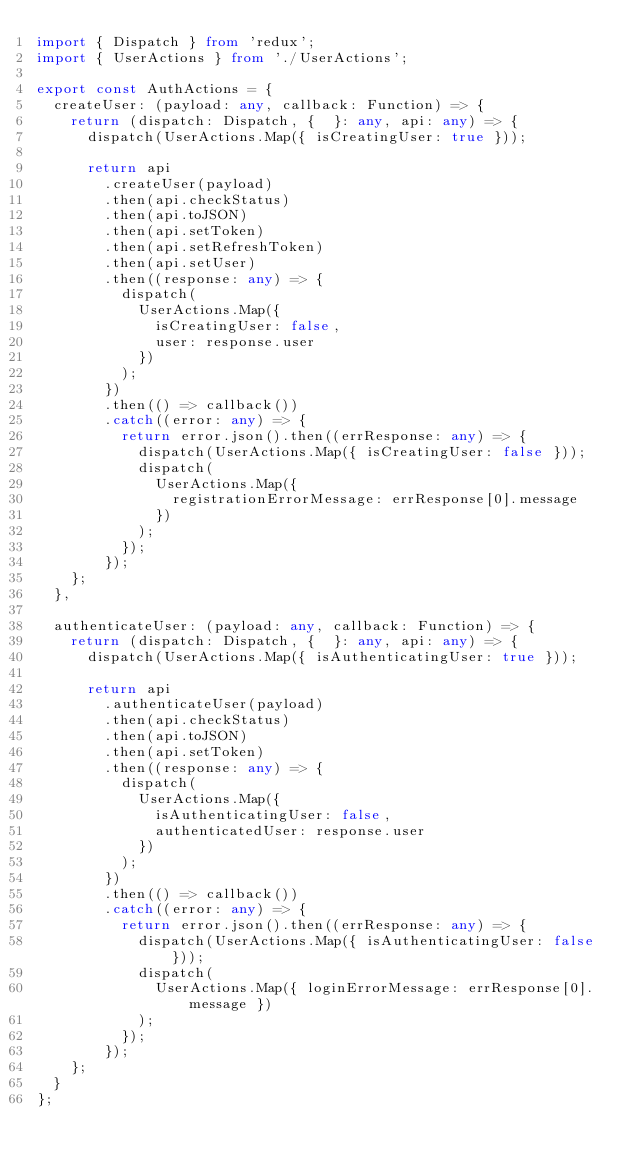Convert code to text. <code><loc_0><loc_0><loc_500><loc_500><_TypeScript_>import { Dispatch } from 'redux';
import { UserActions } from './UserActions';

export const AuthActions = {
  createUser: (payload: any, callback: Function) => {
    return (dispatch: Dispatch, {  }: any, api: any) => {
      dispatch(UserActions.Map({ isCreatingUser: true }));

      return api
        .createUser(payload)
        .then(api.checkStatus)
        .then(api.toJSON)
        .then(api.setToken)
        .then(api.setRefreshToken)
        .then(api.setUser)
        .then((response: any) => {
          dispatch(
            UserActions.Map({
              isCreatingUser: false,
              user: response.user
            })
          );
        })
        .then(() => callback())
        .catch((error: any) => {
          return error.json().then((errResponse: any) => {
            dispatch(UserActions.Map({ isCreatingUser: false }));
            dispatch(
              UserActions.Map({
                registrationErrorMessage: errResponse[0].message
              })
            );
          });
        });
    };
  },

  authenticateUser: (payload: any, callback: Function) => {
    return (dispatch: Dispatch, {  }: any, api: any) => {
      dispatch(UserActions.Map({ isAuthenticatingUser: true }));

      return api
        .authenticateUser(payload)
        .then(api.checkStatus)
        .then(api.toJSON)
        .then(api.setToken)
        .then((response: any) => {
          dispatch(
            UserActions.Map({
              isAuthenticatingUser: false,
              authenticatedUser: response.user
            })
          );
        })
        .then(() => callback())
        .catch((error: any) => {
          return error.json().then((errResponse: any) => {
            dispatch(UserActions.Map({ isAuthenticatingUser: false }));
            dispatch(
              UserActions.Map({ loginErrorMessage: errResponse[0].message })
            );
          });
        });
    };
  }
};
</code> 